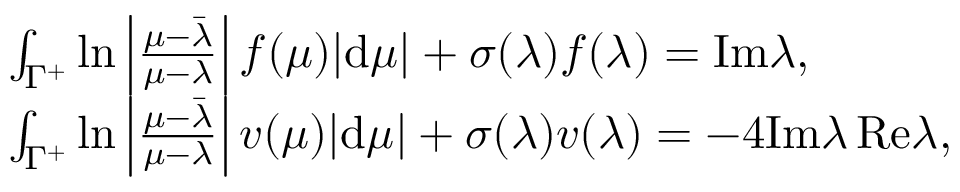Convert formula to latex. <formula><loc_0><loc_0><loc_500><loc_500>\begin{array} { r l } & { \int _ { \Gamma ^ { + } } \ln \left | \frac { \mu - \bar { \lambda } } { \mu - \lambda } \right | f ( \mu ) | d \mu | + \sigma ( \lambda ) f ( \lambda ) = I m \lambda , } \\ & { \int _ { \Gamma ^ { + } } \ln \left | \frac { \mu - \bar { \lambda } } { \mu - \lambda } \right | v ( \mu ) | d \mu | + \sigma ( \lambda ) v ( \lambda ) = - 4 I m \lambda \, R e \lambda , } \end{array}</formula> 